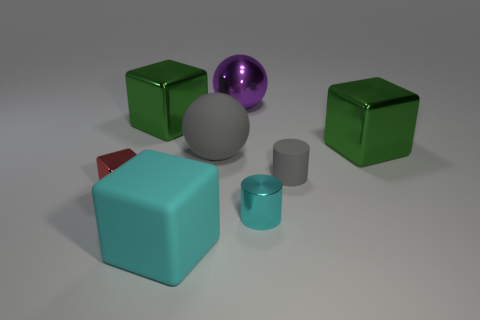Subtract 1 blocks. How many blocks are left? 3 Subtract all yellow cylinders. Subtract all green blocks. How many cylinders are left? 2 Add 2 small shiny objects. How many objects exist? 10 Subtract all cylinders. How many objects are left? 6 Subtract 1 cyan cylinders. How many objects are left? 7 Subtract all big gray shiny cylinders. Subtract all large purple things. How many objects are left? 7 Add 1 metallic cylinders. How many metallic cylinders are left? 2 Add 4 red shiny blocks. How many red shiny blocks exist? 5 